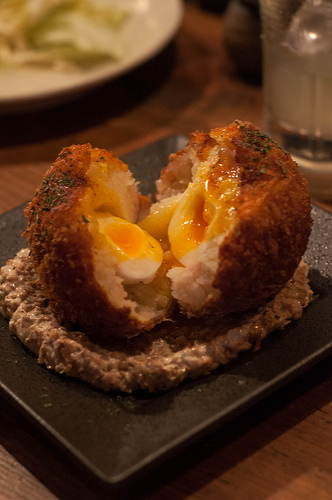<image>
Is there a egg in the bread? Yes. The egg is contained within or inside the bread, showing a containment relationship. Is there a breading in front of the egg? No. The breading is not in front of the egg. The spatial positioning shows a different relationship between these objects. 